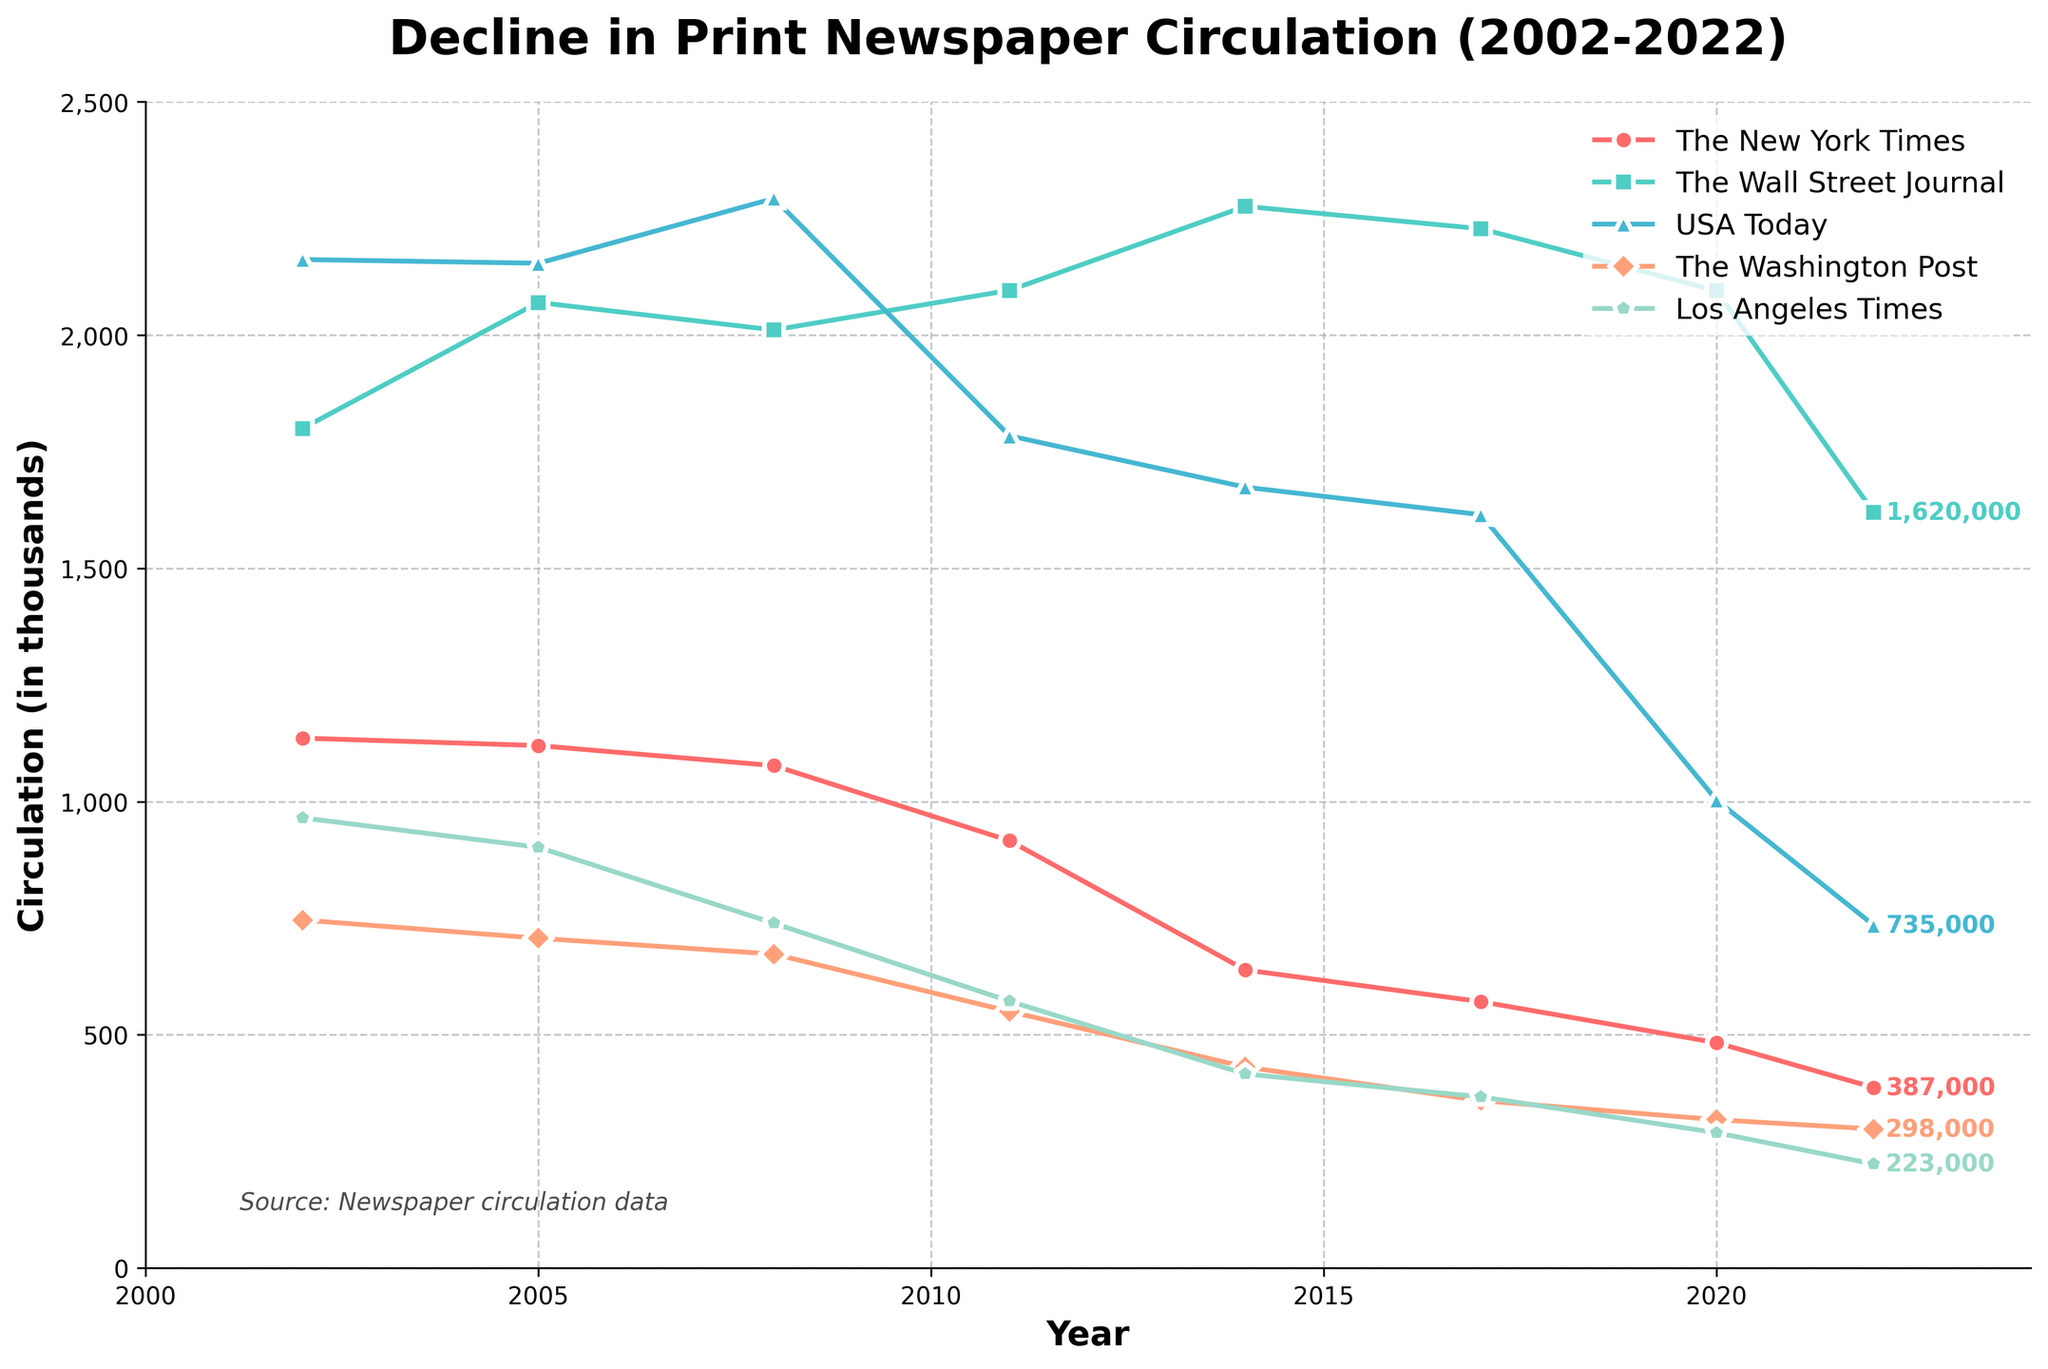What's the difference in circulation between The New York Times and The Wall Street Journal in 2022? First, find the circulation for The New York Times in 2022, which is 387,000. Next, find the circulation for The Wall Street Journal in 2022, which is 1,620,000. Finally, calculate the difference: 1,620,000 - 387,000 = 1,233,000.
Answer: 1,233,000 Which newspaper had the highest circulation in 2008? Check the data points for all newspapers in 2008: The New York Times (1,077,000), The Wall Street Journal (2,011,000), USA Today (2,293,000), The Washington Post (673,000), Los Angeles Times (739,000). The highest value is 2,293,000 for USA Today.
Answer: USA Today How much did the circulation of The Washington Post decrease from 2002 to 2022? First, find the circulation of The Washington Post in 2002, which is 746,000. Then, find the circulation in 2022, which is 298,000. Subtract the 2022 value from the 2002 value: 746,000 - 298,000 = 448,000.
Answer: 448,000 By how many thousand did the circulation of USA Today decrease from 2014 to 2020? In 2014, the circulation of USA Today was 1,674,000. In 2020, it was 1,003,000. Calculate the decrease: 1,674,000 - 1,003,000 = 671,000.
Answer: 671,000 Was there any year when The Wall Street Journal had a decrease in circulation? Observe the line for The Wall Street Journal. All data points show either an increase or a slight decrease, especially from 2017 to 2020 and 2020 to 2022.
Answer: Yes Which newspaper shows the most consistent decline in circulation over the 20-year period? Examine each line for overall trend consistency. The line representing The New York Times shows the most consistent downward slope.
Answer: The New York Times Which year had the largest drop in circulation for the Los Angeles Times? Find consecutive years where the largest drop occurred by comparing values: The biggest drop is between 2008 (739,000) and 2011 (572,000). Calculate the change: 739,000 - 572,000 = 167,000.
Answer: 2008 to 2011 What is the average circulation of The New York Times over the 20-year period? Find the values for The New York Times: 1,136,000 (2002), 1,120,000 (2005), 1,077,000 (2008), 916,000 (2011), 639,000 (2014), 571,000 (2017), 483,000 (2020), 387,000 (2022). Calculate the sum and average: (1,136,000 + 1,120,000 + 1,077,000 + 916,000 + 639,000 + 571,000 + 483,000 + 387,000) / 8 = 791,125.
Answer: 791,125 